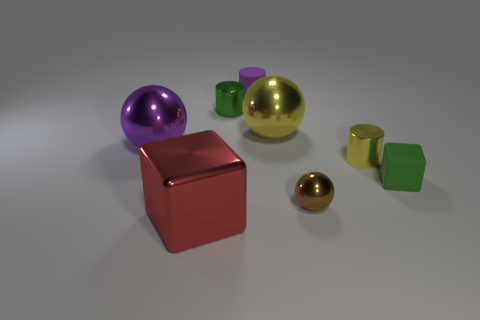Add 2 small green shiny cubes. How many objects exist? 10 Subtract all balls. How many objects are left? 5 Add 3 large purple things. How many large purple things are left? 4 Add 6 brown shiny spheres. How many brown shiny spheres exist? 7 Subtract 1 green cylinders. How many objects are left? 7 Subtract all big green metallic cylinders. Subtract all green cubes. How many objects are left? 7 